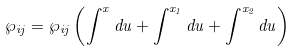Convert formula to latex. <formula><loc_0><loc_0><loc_500><loc_500>\wp _ { i j } = \wp _ { i j } \left ( \int ^ { x } d { u } + \int ^ { x _ { 1 } } d { u } + \int ^ { x _ { 2 } } d { u } \right )</formula> 